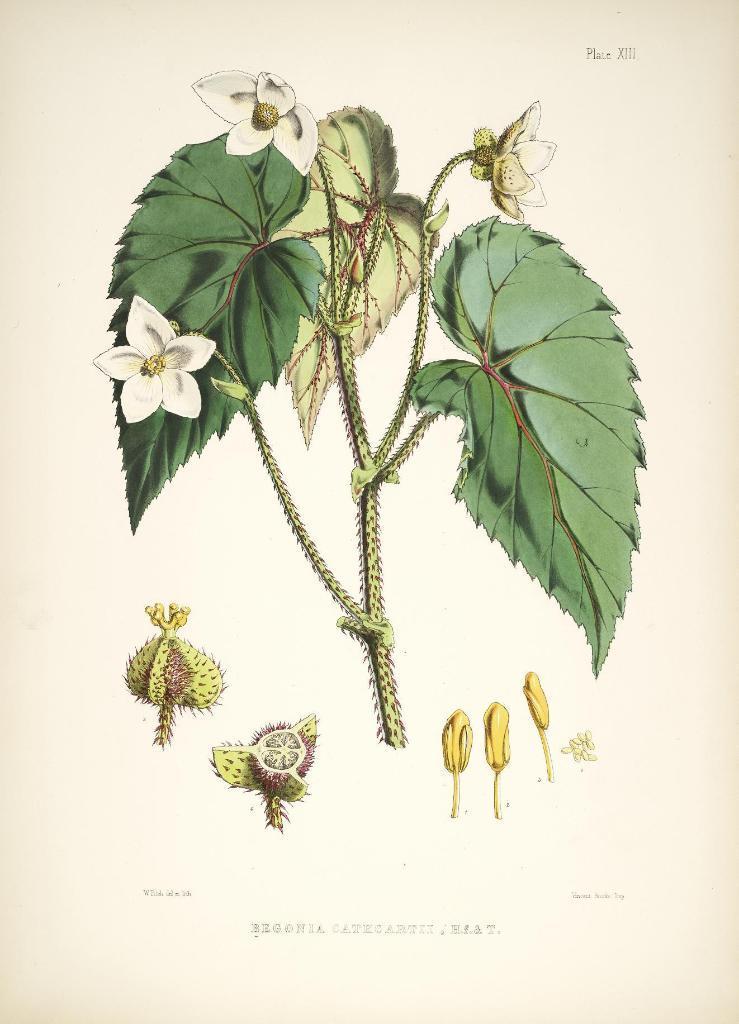How would you summarize this image in a sentence or two? In this picture we can see a flower and few leaves. There are parts of a flower in this image. 